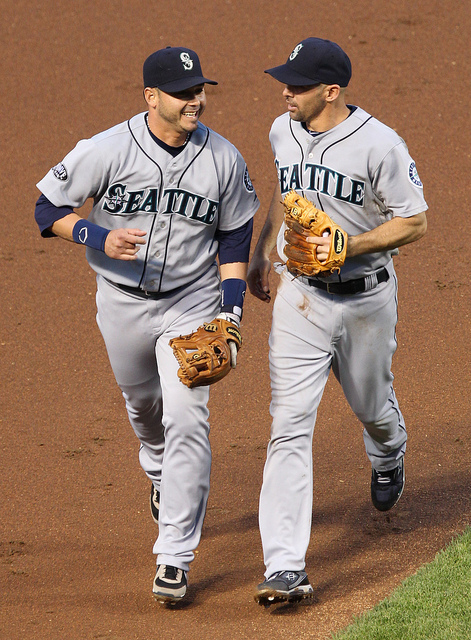Extract all visible text content from this image. SEA TTLE EATTLE 